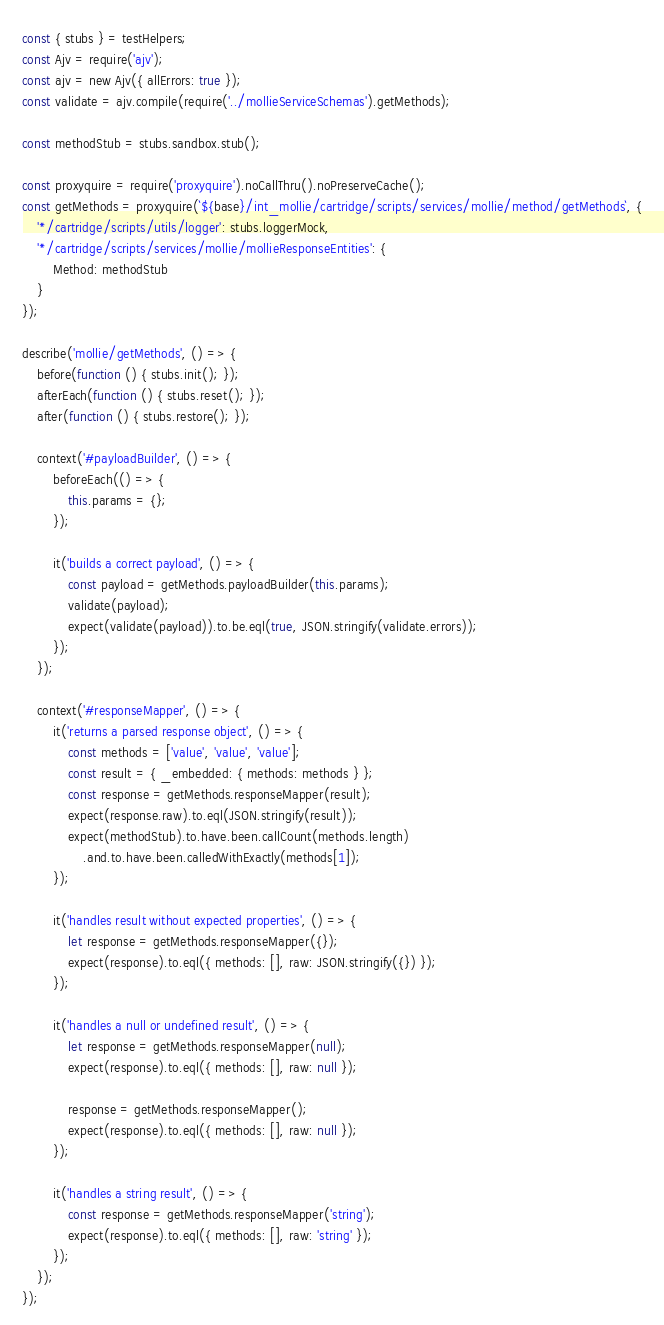<code> <loc_0><loc_0><loc_500><loc_500><_JavaScript_>const { stubs } = testHelpers;
const Ajv = require('ajv');
const ajv = new Ajv({ allErrors: true });
const validate = ajv.compile(require('../mollieServiceSchemas').getMethods);

const methodStub = stubs.sandbox.stub();

const proxyquire = require('proxyquire').noCallThru().noPreserveCache();
const getMethods = proxyquire(`${base}/int_mollie/cartridge/scripts/services/mollie/method/getMethods`, {
    '*/cartridge/scripts/utils/logger': stubs.loggerMock,
    '*/cartridge/scripts/services/mollie/mollieResponseEntities': {
        Method: methodStub
    }
});

describe('mollie/getMethods', () => {
    before(function () { stubs.init(); });
    afterEach(function () { stubs.reset(); });
    after(function () { stubs.restore(); });

    context('#payloadBuilder', () => {
        beforeEach(() => {
            this.params = {};
        });

        it('builds a correct payload', () => {
            const payload = getMethods.payloadBuilder(this.params);
            validate(payload);
            expect(validate(payload)).to.be.eql(true, JSON.stringify(validate.errors));
        });
    });

    context('#responseMapper', () => {
        it('returns a parsed response object', () => {
            const methods = ['value', 'value', 'value'];
            const result = { _embedded: { methods: methods } };
            const response = getMethods.responseMapper(result);
            expect(response.raw).to.eql(JSON.stringify(result));
            expect(methodStub).to.have.been.callCount(methods.length)
                .and.to.have.been.calledWithExactly(methods[1]);
        });

        it('handles result without expected properties', () => {
            let response = getMethods.responseMapper({});
            expect(response).to.eql({ methods: [], raw: JSON.stringify({}) });
        });

        it('handles a null or undefined result', () => {
            let response = getMethods.responseMapper(null);
            expect(response).to.eql({ methods: [], raw: null });

            response = getMethods.responseMapper();
            expect(response).to.eql({ methods: [], raw: null });
        });

        it('handles a string result', () => {
            const response = getMethods.responseMapper('string');
            expect(response).to.eql({ methods: [], raw: 'string' });
        });
    });
});
</code> 